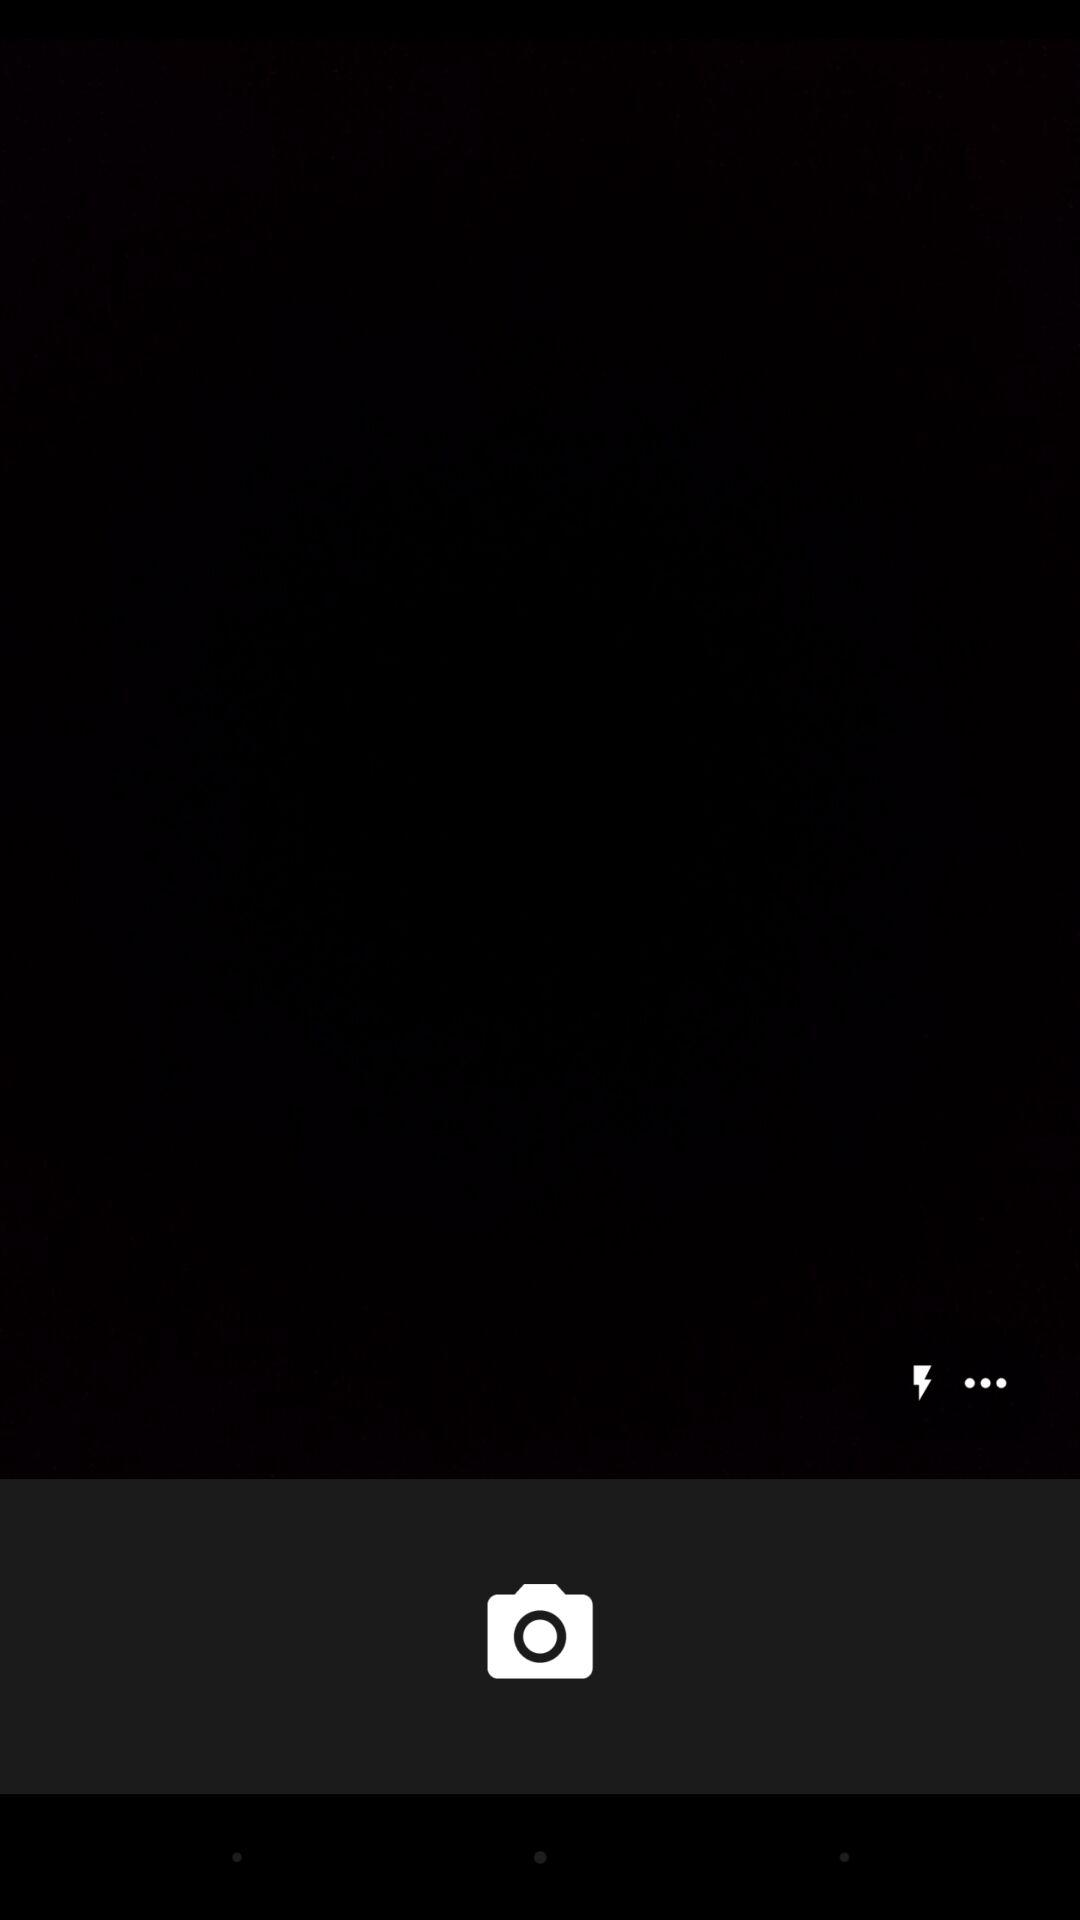How many more dots than lightning bolts are there?
Answer the question using a single word or phrase. 2 